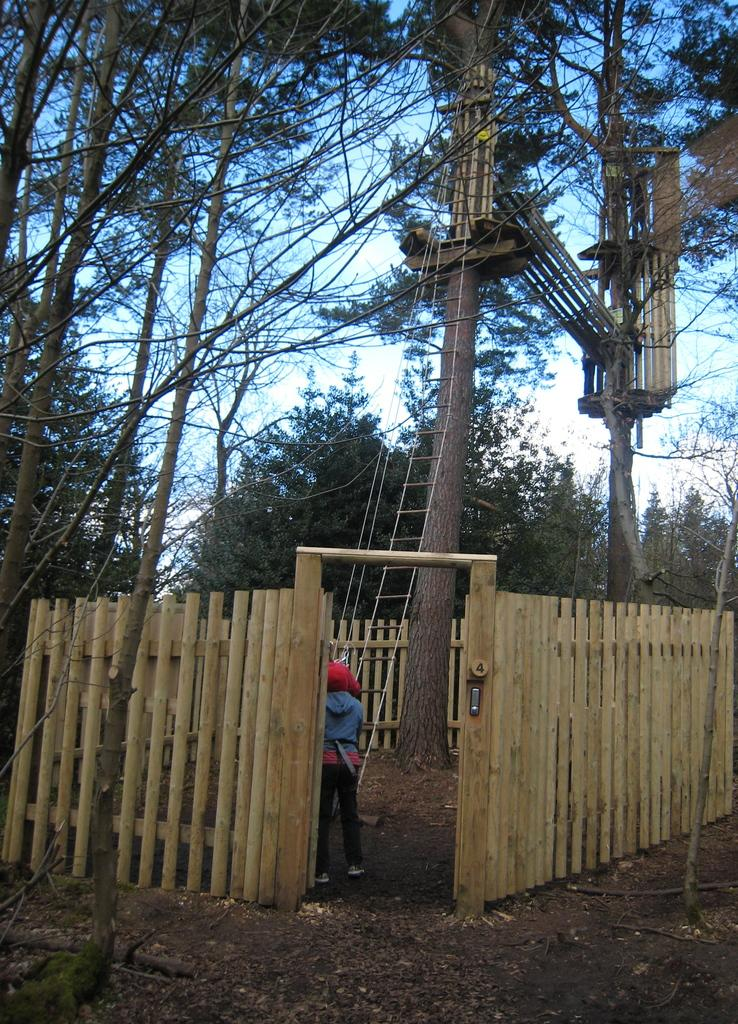What is the person standing in front of in the image? The person is standing in front of a rope ladder. What type of fencing can be seen in the image? There is wooden fencing in the image. What structure is visible in the trees? There is a tree-house in the image. What type of vegetation is present in the image? Trees are present in the image. What is the color of the sky in the image? The sky appears to be white in color. Where is the shelf located in the image? There is no shelf present in the image. How many potatoes can be seen in the image? There are no potatoes present in the image. 